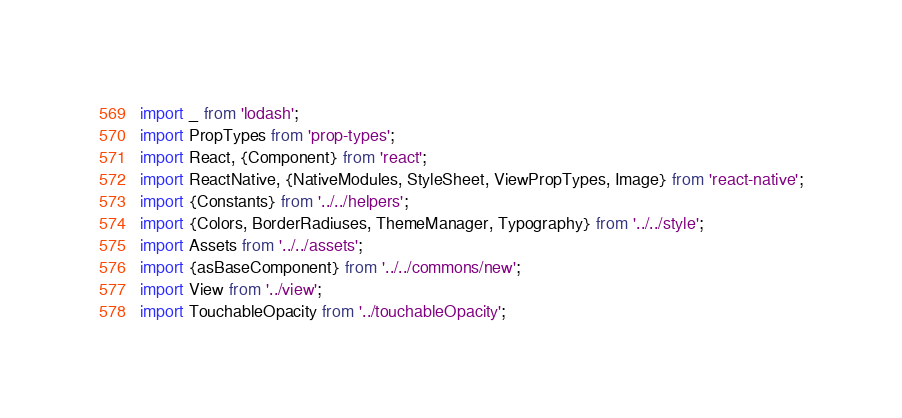<code> <loc_0><loc_0><loc_500><loc_500><_JavaScript_>import _ from 'lodash';
import PropTypes from 'prop-types';
import React, {Component} from 'react';
import ReactNative, {NativeModules, StyleSheet, ViewPropTypes, Image} from 'react-native';
import {Constants} from '../../helpers';
import {Colors, BorderRadiuses, ThemeManager, Typography} from '../../style';
import Assets from '../../assets';
import {asBaseComponent} from '../../commons/new';
import View from '../view';
import TouchableOpacity from '../touchableOpacity';</code> 